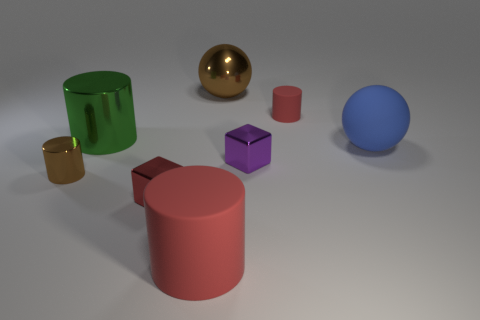Can you describe the arrangement of the objects on the surface? The objects are arranged asymmetrically on a flat surface. There's a large green cylinder on the left, with a small golden cube and a medium-sized red cylinder placed in front of it. In the center, there's a medium-sized, shiny golden sphere, a purple cube, and a medium blue sphere arranged in a triangular fashion. The arrangement has an organized randomness, each object getting enough space to stand out. 